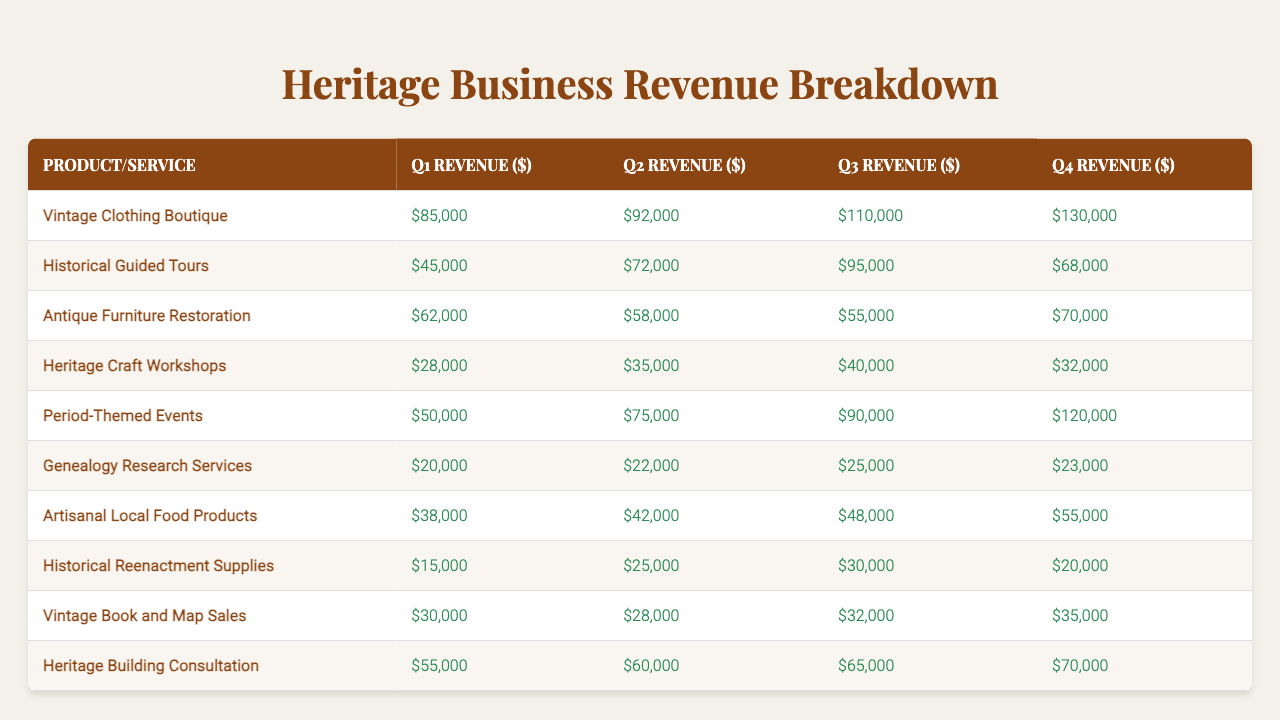What is the revenue from the Vintage Clothing Boutique in Q3? Looking at the row for Vintage Clothing Boutique, the revenue for Q3 is listed directly in the table as $110,000.
Answer: $110,000 Which heritage-themed product had the highest revenue in Q4? The Q4 revenues for each product/service are compared: Vintage Clothing Boutique ($130,000), Historical Guided Tours ($68,000), Antique Furniture Restoration ($70,000), Heritage Craft Workshops ($32,000), Period-Themed Events ($120,000), Genealogy Research Services ($23,000), Artisanal Local Food Products ($55,000), Historical Reenactment Supplies ($20,000), Vintage Book and Map Sales ($35,000), Heritage Building Consultation ($70,000). Vintage Clothing Boutique had the highest revenue at $130,000.
Answer: Vintage Clothing Boutique What is the total revenue from Historical Guided Tours over the four quarters? The revenues for Historical Guided Tours are $45,000 in Q1, $72,000 in Q2, $95,000 in Q3, and $68,000 in Q4. Adding these amounts gives $45,000 + $72,000 + $95,000 + $68,000 = $280,000.
Answer: $280,000 Which product/service had the lowest revenue in Q2? The Q2 revenues of each product/service are compared. The minimum value is found by scanning through the table: Genealogy Research Services at $22,000 has the lowest revenue in Q2.
Answer: Genealogy Research Services What was the average revenue for the Antique Furniture Restoration service across all four quarters? The revenues for Antique Furniture Restoration are $62,000 in Q1, $58,000 in Q2, $55,000 in Q3, and $70,000 in Q4. Summing these gives $62,000 + $58,000 + $55,000 + $70,000 = $245,000. Dividing by 4 for the average gives $245,000 / 4 = $61,250.
Answer: $61,250 Did the revenue from Heritage Craft Workshops increase or decrease from Q1 to Q4? The revenue for Heritage Craft Workshops in Q1 is $28,000 and in Q4 is $32,000. This shows an increase since $32,000 is higher than $28,000.
Answer: Increase What is the difference between the Q3 revenue of Period-Themed Events and the Q2 revenue of Historical Guided Tours? The revenue for Period-Themed Events in Q3 is $90,000, and for Historical Guided Tours in Q2 is $72,000. The difference is calculated as $90,000 - $72,000 = $18,000.
Answer: $18,000 Which product/service saw the least consistent revenue growth across the quarters? To determine consistency, we compare the revenues quarterly for all services. Antique Furniture Restoration shows a drop from Q1 ($62,000) to Q3 ($55,000) then an increase to Q4 ($70,000), indicating less consistent growth compared to others that show steady increases or decreases.
Answer: Antique Furniture Restoration What was the combined revenue of the top three highest-earning products in Q4? The top three earners in Q4 are Vintage Clothing Boutique ($130,000), Period-Themed Events ($120,000), and Heritage Building Consultation ($70,000). Their combined revenue is $130,000 + $120,000 + $70,000 = $320,000.
Answer: $320,000 Was there ever a quarter where Genealogy Research Services earned more than $25,000? Scanning through the revenues, Genealogy Research Services earned $20,000 in Q1, $22,000 in Q2, $25,000 in Q3, and $23,000 in Q4. It only reached exactly $25,000 in Q3, which counts as not earning more than $25,000 in any quarter.
Answer: No 